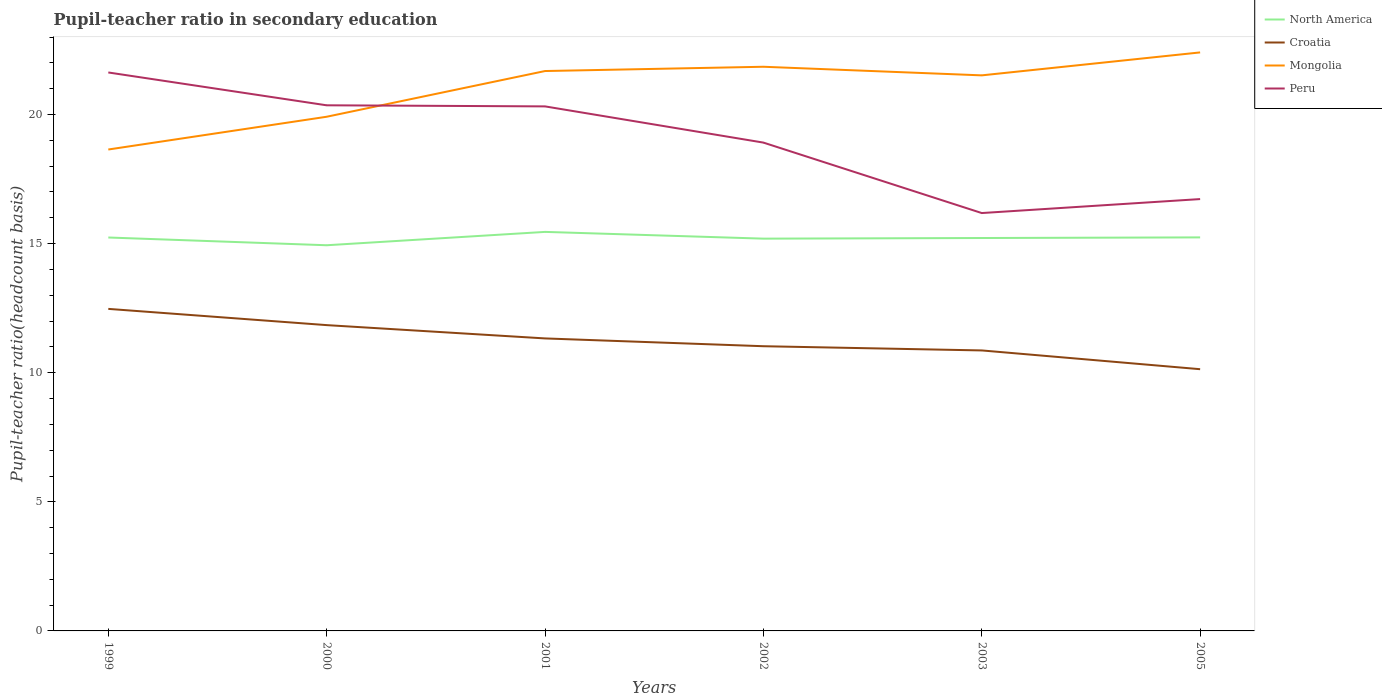How many different coloured lines are there?
Offer a very short reply. 4. Across all years, what is the maximum pupil-teacher ratio in secondary education in North America?
Offer a very short reply. 14.94. In which year was the pupil-teacher ratio in secondary education in North America maximum?
Provide a succinct answer. 2000. What is the total pupil-teacher ratio in secondary education in Peru in the graph?
Give a very brief answer. 1.4. What is the difference between the highest and the second highest pupil-teacher ratio in secondary education in Mongolia?
Your answer should be very brief. 3.76. What is the difference between the highest and the lowest pupil-teacher ratio in secondary education in Croatia?
Your answer should be compact. 3. How many years are there in the graph?
Your response must be concise. 6. What is the difference between two consecutive major ticks on the Y-axis?
Your answer should be very brief. 5. Are the values on the major ticks of Y-axis written in scientific E-notation?
Your response must be concise. No. How many legend labels are there?
Ensure brevity in your answer.  4. What is the title of the graph?
Your answer should be very brief. Pupil-teacher ratio in secondary education. What is the label or title of the X-axis?
Make the answer very short. Years. What is the label or title of the Y-axis?
Ensure brevity in your answer.  Pupil-teacher ratio(headcount basis). What is the Pupil-teacher ratio(headcount basis) of North America in 1999?
Your answer should be very brief. 15.24. What is the Pupil-teacher ratio(headcount basis) of Croatia in 1999?
Give a very brief answer. 12.47. What is the Pupil-teacher ratio(headcount basis) in Mongolia in 1999?
Provide a succinct answer. 18.65. What is the Pupil-teacher ratio(headcount basis) of Peru in 1999?
Provide a succinct answer. 21.63. What is the Pupil-teacher ratio(headcount basis) in North America in 2000?
Your answer should be compact. 14.94. What is the Pupil-teacher ratio(headcount basis) of Croatia in 2000?
Your response must be concise. 11.84. What is the Pupil-teacher ratio(headcount basis) in Mongolia in 2000?
Make the answer very short. 19.91. What is the Pupil-teacher ratio(headcount basis) of Peru in 2000?
Provide a succinct answer. 20.36. What is the Pupil-teacher ratio(headcount basis) in North America in 2001?
Make the answer very short. 15.45. What is the Pupil-teacher ratio(headcount basis) of Croatia in 2001?
Give a very brief answer. 11.33. What is the Pupil-teacher ratio(headcount basis) of Mongolia in 2001?
Your answer should be compact. 21.68. What is the Pupil-teacher ratio(headcount basis) in Peru in 2001?
Offer a terse response. 20.32. What is the Pupil-teacher ratio(headcount basis) of North America in 2002?
Offer a terse response. 15.19. What is the Pupil-teacher ratio(headcount basis) of Croatia in 2002?
Make the answer very short. 11.03. What is the Pupil-teacher ratio(headcount basis) in Mongolia in 2002?
Provide a succinct answer. 21.85. What is the Pupil-teacher ratio(headcount basis) of Peru in 2002?
Provide a short and direct response. 18.91. What is the Pupil-teacher ratio(headcount basis) of North America in 2003?
Your answer should be compact. 15.22. What is the Pupil-teacher ratio(headcount basis) of Croatia in 2003?
Offer a very short reply. 10.86. What is the Pupil-teacher ratio(headcount basis) of Mongolia in 2003?
Offer a very short reply. 21.52. What is the Pupil-teacher ratio(headcount basis) of Peru in 2003?
Give a very brief answer. 16.18. What is the Pupil-teacher ratio(headcount basis) in North America in 2005?
Offer a very short reply. 15.24. What is the Pupil-teacher ratio(headcount basis) in Croatia in 2005?
Your response must be concise. 10.14. What is the Pupil-teacher ratio(headcount basis) of Mongolia in 2005?
Provide a short and direct response. 22.41. What is the Pupil-teacher ratio(headcount basis) of Peru in 2005?
Your response must be concise. 16.73. Across all years, what is the maximum Pupil-teacher ratio(headcount basis) in North America?
Your answer should be compact. 15.45. Across all years, what is the maximum Pupil-teacher ratio(headcount basis) of Croatia?
Offer a very short reply. 12.47. Across all years, what is the maximum Pupil-teacher ratio(headcount basis) in Mongolia?
Give a very brief answer. 22.41. Across all years, what is the maximum Pupil-teacher ratio(headcount basis) of Peru?
Provide a succinct answer. 21.63. Across all years, what is the minimum Pupil-teacher ratio(headcount basis) in North America?
Offer a terse response. 14.94. Across all years, what is the minimum Pupil-teacher ratio(headcount basis) in Croatia?
Offer a very short reply. 10.14. Across all years, what is the minimum Pupil-teacher ratio(headcount basis) of Mongolia?
Your answer should be very brief. 18.65. Across all years, what is the minimum Pupil-teacher ratio(headcount basis) in Peru?
Your answer should be compact. 16.18. What is the total Pupil-teacher ratio(headcount basis) in North America in the graph?
Your response must be concise. 91.28. What is the total Pupil-teacher ratio(headcount basis) in Croatia in the graph?
Your response must be concise. 67.67. What is the total Pupil-teacher ratio(headcount basis) in Mongolia in the graph?
Give a very brief answer. 126.02. What is the total Pupil-teacher ratio(headcount basis) in Peru in the graph?
Keep it short and to the point. 114.13. What is the difference between the Pupil-teacher ratio(headcount basis) in North America in 1999 and that in 2000?
Offer a terse response. 0.3. What is the difference between the Pupil-teacher ratio(headcount basis) of Croatia in 1999 and that in 2000?
Offer a very short reply. 0.63. What is the difference between the Pupil-teacher ratio(headcount basis) in Mongolia in 1999 and that in 2000?
Provide a succinct answer. -1.27. What is the difference between the Pupil-teacher ratio(headcount basis) in Peru in 1999 and that in 2000?
Provide a short and direct response. 1.27. What is the difference between the Pupil-teacher ratio(headcount basis) of North America in 1999 and that in 2001?
Offer a very short reply. -0.22. What is the difference between the Pupil-teacher ratio(headcount basis) in Croatia in 1999 and that in 2001?
Your answer should be compact. 1.14. What is the difference between the Pupil-teacher ratio(headcount basis) of Mongolia in 1999 and that in 2001?
Make the answer very short. -3.04. What is the difference between the Pupil-teacher ratio(headcount basis) of Peru in 1999 and that in 2001?
Offer a very short reply. 1.31. What is the difference between the Pupil-teacher ratio(headcount basis) in North America in 1999 and that in 2002?
Provide a short and direct response. 0.04. What is the difference between the Pupil-teacher ratio(headcount basis) of Croatia in 1999 and that in 2002?
Your answer should be very brief. 1.45. What is the difference between the Pupil-teacher ratio(headcount basis) of Mongolia in 1999 and that in 2002?
Your answer should be compact. -3.21. What is the difference between the Pupil-teacher ratio(headcount basis) in Peru in 1999 and that in 2002?
Offer a terse response. 2.72. What is the difference between the Pupil-teacher ratio(headcount basis) in North America in 1999 and that in 2003?
Your answer should be very brief. 0.02. What is the difference between the Pupil-teacher ratio(headcount basis) of Croatia in 1999 and that in 2003?
Your response must be concise. 1.61. What is the difference between the Pupil-teacher ratio(headcount basis) of Mongolia in 1999 and that in 2003?
Your answer should be compact. -2.87. What is the difference between the Pupil-teacher ratio(headcount basis) in Peru in 1999 and that in 2003?
Your answer should be very brief. 5.44. What is the difference between the Pupil-teacher ratio(headcount basis) of North America in 1999 and that in 2005?
Give a very brief answer. -0. What is the difference between the Pupil-teacher ratio(headcount basis) in Croatia in 1999 and that in 2005?
Offer a very short reply. 2.34. What is the difference between the Pupil-teacher ratio(headcount basis) of Mongolia in 1999 and that in 2005?
Provide a short and direct response. -3.76. What is the difference between the Pupil-teacher ratio(headcount basis) of Peru in 1999 and that in 2005?
Keep it short and to the point. 4.9. What is the difference between the Pupil-teacher ratio(headcount basis) in North America in 2000 and that in 2001?
Your answer should be very brief. -0.52. What is the difference between the Pupil-teacher ratio(headcount basis) of Croatia in 2000 and that in 2001?
Offer a very short reply. 0.52. What is the difference between the Pupil-teacher ratio(headcount basis) in Mongolia in 2000 and that in 2001?
Provide a succinct answer. -1.77. What is the difference between the Pupil-teacher ratio(headcount basis) in Peru in 2000 and that in 2001?
Your answer should be compact. 0.04. What is the difference between the Pupil-teacher ratio(headcount basis) in North America in 2000 and that in 2002?
Provide a succinct answer. -0.26. What is the difference between the Pupil-teacher ratio(headcount basis) of Croatia in 2000 and that in 2002?
Make the answer very short. 0.82. What is the difference between the Pupil-teacher ratio(headcount basis) in Mongolia in 2000 and that in 2002?
Your answer should be very brief. -1.94. What is the difference between the Pupil-teacher ratio(headcount basis) of Peru in 2000 and that in 2002?
Provide a succinct answer. 1.44. What is the difference between the Pupil-teacher ratio(headcount basis) in North America in 2000 and that in 2003?
Make the answer very short. -0.28. What is the difference between the Pupil-teacher ratio(headcount basis) in Croatia in 2000 and that in 2003?
Provide a short and direct response. 0.98. What is the difference between the Pupil-teacher ratio(headcount basis) of Mongolia in 2000 and that in 2003?
Ensure brevity in your answer.  -1.6. What is the difference between the Pupil-teacher ratio(headcount basis) in Peru in 2000 and that in 2003?
Keep it short and to the point. 4.17. What is the difference between the Pupil-teacher ratio(headcount basis) in North America in 2000 and that in 2005?
Provide a short and direct response. -0.3. What is the difference between the Pupil-teacher ratio(headcount basis) in Croatia in 2000 and that in 2005?
Your answer should be compact. 1.71. What is the difference between the Pupil-teacher ratio(headcount basis) of Mongolia in 2000 and that in 2005?
Offer a very short reply. -2.49. What is the difference between the Pupil-teacher ratio(headcount basis) in Peru in 2000 and that in 2005?
Offer a terse response. 3.63. What is the difference between the Pupil-teacher ratio(headcount basis) in North America in 2001 and that in 2002?
Give a very brief answer. 0.26. What is the difference between the Pupil-teacher ratio(headcount basis) of Croatia in 2001 and that in 2002?
Offer a terse response. 0.3. What is the difference between the Pupil-teacher ratio(headcount basis) in Mongolia in 2001 and that in 2002?
Make the answer very short. -0.17. What is the difference between the Pupil-teacher ratio(headcount basis) in Peru in 2001 and that in 2002?
Make the answer very short. 1.4. What is the difference between the Pupil-teacher ratio(headcount basis) in North America in 2001 and that in 2003?
Give a very brief answer. 0.24. What is the difference between the Pupil-teacher ratio(headcount basis) of Croatia in 2001 and that in 2003?
Your answer should be very brief. 0.46. What is the difference between the Pupil-teacher ratio(headcount basis) in Mongolia in 2001 and that in 2003?
Give a very brief answer. 0.17. What is the difference between the Pupil-teacher ratio(headcount basis) in Peru in 2001 and that in 2003?
Offer a terse response. 4.13. What is the difference between the Pupil-teacher ratio(headcount basis) in North America in 2001 and that in 2005?
Ensure brevity in your answer.  0.21. What is the difference between the Pupil-teacher ratio(headcount basis) in Croatia in 2001 and that in 2005?
Offer a very short reply. 1.19. What is the difference between the Pupil-teacher ratio(headcount basis) of Mongolia in 2001 and that in 2005?
Make the answer very short. -0.72. What is the difference between the Pupil-teacher ratio(headcount basis) of Peru in 2001 and that in 2005?
Your response must be concise. 3.59. What is the difference between the Pupil-teacher ratio(headcount basis) of North America in 2002 and that in 2003?
Keep it short and to the point. -0.02. What is the difference between the Pupil-teacher ratio(headcount basis) of Croatia in 2002 and that in 2003?
Offer a very short reply. 0.16. What is the difference between the Pupil-teacher ratio(headcount basis) of Mongolia in 2002 and that in 2003?
Provide a short and direct response. 0.33. What is the difference between the Pupil-teacher ratio(headcount basis) of Peru in 2002 and that in 2003?
Make the answer very short. 2.73. What is the difference between the Pupil-teacher ratio(headcount basis) of North America in 2002 and that in 2005?
Provide a short and direct response. -0.05. What is the difference between the Pupil-teacher ratio(headcount basis) in Croatia in 2002 and that in 2005?
Give a very brief answer. 0.89. What is the difference between the Pupil-teacher ratio(headcount basis) of Mongolia in 2002 and that in 2005?
Ensure brevity in your answer.  -0.56. What is the difference between the Pupil-teacher ratio(headcount basis) of Peru in 2002 and that in 2005?
Keep it short and to the point. 2.19. What is the difference between the Pupil-teacher ratio(headcount basis) in North America in 2003 and that in 2005?
Make the answer very short. -0.02. What is the difference between the Pupil-teacher ratio(headcount basis) in Croatia in 2003 and that in 2005?
Make the answer very short. 0.73. What is the difference between the Pupil-teacher ratio(headcount basis) in Mongolia in 2003 and that in 2005?
Ensure brevity in your answer.  -0.89. What is the difference between the Pupil-teacher ratio(headcount basis) in Peru in 2003 and that in 2005?
Provide a succinct answer. -0.54. What is the difference between the Pupil-teacher ratio(headcount basis) in North America in 1999 and the Pupil-teacher ratio(headcount basis) in Croatia in 2000?
Your answer should be compact. 3.39. What is the difference between the Pupil-teacher ratio(headcount basis) of North America in 1999 and the Pupil-teacher ratio(headcount basis) of Mongolia in 2000?
Offer a terse response. -4.68. What is the difference between the Pupil-teacher ratio(headcount basis) of North America in 1999 and the Pupil-teacher ratio(headcount basis) of Peru in 2000?
Keep it short and to the point. -5.12. What is the difference between the Pupil-teacher ratio(headcount basis) of Croatia in 1999 and the Pupil-teacher ratio(headcount basis) of Mongolia in 2000?
Provide a short and direct response. -7.44. What is the difference between the Pupil-teacher ratio(headcount basis) of Croatia in 1999 and the Pupil-teacher ratio(headcount basis) of Peru in 2000?
Ensure brevity in your answer.  -7.88. What is the difference between the Pupil-teacher ratio(headcount basis) in Mongolia in 1999 and the Pupil-teacher ratio(headcount basis) in Peru in 2000?
Your answer should be compact. -1.71. What is the difference between the Pupil-teacher ratio(headcount basis) in North America in 1999 and the Pupil-teacher ratio(headcount basis) in Croatia in 2001?
Offer a terse response. 3.91. What is the difference between the Pupil-teacher ratio(headcount basis) of North America in 1999 and the Pupil-teacher ratio(headcount basis) of Mongolia in 2001?
Give a very brief answer. -6.45. What is the difference between the Pupil-teacher ratio(headcount basis) of North America in 1999 and the Pupil-teacher ratio(headcount basis) of Peru in 2001?
Make the answer very short. -5.08. What is the difference between the Pupil-teacher ratio(headcount basis) of Croatia in 1999 and the Pupil-teacher ratio(headcount basis) of Mongolia in 2001?
Offer a terse response. -9.21. What is the difference between the Pupil-teacher ratio(headcount basis) in Croatia in 1999 and the Pupil-teacher ratio(headcount basis) in Peru in 2001?
Offer a terse response. -7.84. What is the difference between the Pupil-teacher ratio(headcount basis) of Mongolia in 1999 and the Pupil-teacher ratio(headcount basis) of Peru in 2001?
Your answer should be compact. -1.67. What is the difference between the Pupil-teacher ratio(headcount basis) of North America in 1999 and the Pupil-teacher ratio(headcount basis) of Croatia in 2002?
Offer a very short reply. 4.21. What is the difference between the Pupil-teacher ratio(headcount basis) in North America in 1999 and the Pupil-teacher ratio(headcount basis) in Mongolia in 2002?
Offer a terse response. -6.61. What is the difference between the Pupil-teacher ratio(headcount basis) of North America in 1999 and the Pupil-teacher ratio(headcount basis) of Peru in 2002?
Make the answer very short. -3.68. What is the difference between the Pupil-teacher ratio(headcount basis) of Croatia in 1999 and the Pupil-teacher ratio(headcount basis) of Mongolia in 2002?
Make the answer very short. -9.38. What is the difference between the Pupil-teacher ratio(headcount basis) in Croatia in 1999 and the Pupil-teacher ratio(headcount basis) in Peru in 2002?
Your answer should be very brief. -6.44. What is the difference between the Pupil-teacher ratio(headcount basis) of Mongolia in 1999 and the Pupil-teacher ratio(headcount basis) of Peru in 2002?
Make the answer very short. -0.27. What is the difference between the Pupil-teacher ratio(headcount basis) of North America in 1999 and the Pupil-teacher ratio(headcount basis) of Croatia in 2003?
Your answer should be compact. 4.37. What is the difference between the Pupil-teacher ratio(headcount basis) in North America in 1999 and the Pupil-teacher ratio(headcount basis) in Mongolia in 2003?
Your answer should be very brief. -6.28. What is the difference between the Pupil-teacher ratio(headcount basis) of North America in 1999 and the Pupil-teacher ratio(headcount basis) of Peru in 2003?
Make the answer very short. -0.95. What is the difference between the Pupil-teacher ratio(headcount basis) of Croatia in 1999 and the Pupil-teacher ratio(headcount basis) of Mongolia in 2003?
Provide a succinct answer. -9.04. What is the difference between the Pupil-teacher ratio(headcount basis) in Croatia in 1999 and the Pupil-teacher ratio(headcount basis) in Peru in 2003?
Make the answer very short. -3.71. What is the difference between the Pupil-teacher ratio(headcount basis) in Mongolia in 1999 and the Pupil-teacher ratio(headcount basis) in Peru in 2003?
Keep it short and to the point. 2.46. What is the difference between the Pupil-teacher ratio(headcount basis) of North America in 1999 and the Pupil-teacher ratio(headcount basis) of Croatia in 2005?
Provide a short and direct response. 5.1. What is the difference between the Pupil-teacher ratio(headcount basis) in North America in 1999 and the Pupil-teacher ratio(headcount basis) in Mongolia in 2005?
Your response must be concise. -7.17. What is the difference between the Pupil-teacher ratio(headcount basis) of North America in 1999 and the Pupil-teacher ratio(headcount basis) of Peru in 2005?
Provide a short and direct response. -1.49. What is the difference between the Pupil-teacher ratio(headcount basis) of Croatia in 1999 and the Pupil-teacher ratio(headcount basis) of Mongolia in 2005?
Offer a very short reply. -9.93. What is the difference between the Pupil-teacher ratio(headcount basis) of Croatia in 1999 and the Pupil-teacher ratio(headcount basis) of Peru in 2005?
Keep it short and to the point. -4.25. What is the difference between the Pupil-teacher ratio(headcount basis) in Mongolia in 1999 and the Pupil-teacher ratio(headcount basis) in Peru in 2005?
Give a very brief answer. 1.92. What is the difference between the Pupil-teacher ratio(headcount basis) of North America in 2000 and the Pupil-teacher ratio(headcount basis) of Croatia in 2001?
Your response must be concise. 3.61. What is the difference between the Pupil-teacher ratio(headcount basis) of North America in 2000 and the Pupil-teacher ratio(headcount basis) of Mongolia in 2001?
Your response must be concise. -6.75. What is the difference between the Pupil-teacher ratio(headcount basis) in North America in 2000 and the Pupil-teacher ratio(headcount basis) in Peru in 2001?
Provide a succinct answer. -5.38. What is the difference between the Pupil-teacher ratio(headcount basis) of Croatia in 2000 and the Pupil-teacher ratio(headcount basis) of Mongolia in 2001?
Provide a succinct answer. -9.84. What is the difference between the Pupil-teacher ratio(headcount basis) in Croatia in 2000 and the Pupil-teacher ratio(headcount basis) in Peru in 2001?
Provide a short and direct response. -8.47. What is the difference between the Pupil-teacher ratio(headcount basis) in Mongolia in 2000 and the Pupil-teacher ratio(headcount basis) in Peru in 2001?
Provide a succinct answer. -0.4. What is the difference between the Pupil-teacher ratio(headcount basis) of North America in 2000 and the Pupil-teacher ratio(headcount basis) of Croatia in 2002?
Ensure brevity in your answer.  3.91. What is the difference between the Pupil-teacher ratio(headcount basis) in North America in 2000 and the Pupil-teacher ratio(headcount basis) in Mongolia in 2002?
Offer a terse response. -6.91. What is the difference between the Pupil-teacher ratio(headcount basis) in North America in 2000 and the Pupil-teacher ratio(headcount basis) in Peru in 2002?
Provide a short and direct response. -3.98. What is the difference between the Pupil-teacher ratio(headcount basis) of Croatia in 2000 and the Pupil-teacher ratio(headcount basis) of Mongolia in 2002?
Give a very brief answer. -10.01. What is the difference between the Pupil-teacher ratio(headcount basis) of Croatia in 2000 and the Pupil-teacher ratio(headcount basis) of Peru in 2002?
Keep it short and to the point. -7.07. What is the difference between the Pupil-teacher ratio(headcount basis) of North America in 2000 and the Pupil-teacher ratio(headcount basis) of Croatia in 2003?
Give a very brief answer. 4.07. What is the difference between the Pupil-teacher ratio(headcount basis) of North America in 2000 and the Pupil-teacher ratio(headcount basis) of Mongolia in 2003?
Make the answer very short. -6.58. What is the difference between the Pupil-teacher ratio(headcount basis) in North America in 2000 and the Pupil-teacher ratio(headcount basis) in Peru in 2003?
Make the answer very short. -1.25. What is the difference between the Pupil-teacher ratio(headcount basis) in Croatia in 2000 and the Pupil-teacher ratio(headcount basis) in Mongolia in 2003?
Offer a terse response. -9.67. What is the difference between the Pupil-teacher ratio(headcount basis) of Croatia in 2000 and the Pupil-teacher ratio(headcount basis) of Peru in 2003?
Offer a terse response. -4.34. What is the difference between the Pupil-teacher ratio(headcount basis) of Mongolia in 2000 and the Pupil-teacher ratio(headcount basis) of Peru in 2003?
Keep it short and to the point. 3.73. What is the difference between the Pupil-teacher ratio(headcount basis) in North America in 2000 and the Pupil-teacher ratio(headcount basis) in Croatia in 2005?
Your response must be concise. 4.8. What is the difference between the Pupil-teacher ratio(headcount basis) of North America in 2000 and the Pupil-teacher ratio(headcount basis) of Mongolia in 2005?
Give a very brief answer. -7.47. What is the difference between the Pupil-teacher ratio(headcount basis) in North America in 2000 and the Pupil-teacher ratio(headcount basis) in Peru in 2005?
Provide a succinct answer. -1.79. What is the difference between the Pupil-teacher ratio(headcount basis) of Croatia in 2000 and the Pupil-teacher ratio(headcount basis) of Mongolia in 2005?
Provide a short and direct response. -10.56. What is the difference between the Pupil-teacher ratio(headcount basis) in Croatia in 2000 and the Pupil-teacher ratio(headcount basis) in Peru in 2005?
Provide a short and direct response. -4.88. What is the difference between the Pupil-teacher ratio(headcount basis) of Mongolia in 2000 and the Pupil-teacher ratio(headcount basis) of Peru in 2005?
Offer a very short reply. 3.19. What is the difference between the Pupil-teacher ratio(headcount basis) in North America in 2001 and the Pupil-teacher ratio(headcount basis) in Croatia in 2002?
Offer a very short reply. 4.43. What is the difference between the Pupil-teacher ratio(headcount basis) in North America in 2001 and the Pupil-teacher ratio(headcount basis) in Mongolia in 2002?
Your response must be concise. -6.4. What is the difference between the Pupil-teacher ratio(headcount basis) of North America in 2001 and the Pupil-teacher ratio(headcount basis) of Peru in 2002?
Make the answer very short. -3.46. What is the difference between the Pupil-teacher ratio(headcount basis) in Croatia in 2001 and the Pupil-teacher ratio(headcount basis) in Mongolia in 2002?
Make the answer very short. -10.52. What is the difference between the Pupil-teacher ratio(headcount basis) in Croatia in 2001 and the Pupil-teacher ratio(headcount basis) in Peru in 2002?
Offer a very short reply. -7.58. What is the difference between the Pupil-teacher ratio(headcount basis) of Mongolia in 2001 and the Pupil-teacher ratio(headcount basis) of Peru in 2002?
Offer a terse response. 2.77. What is the difference between the Pupil-teacher ratio(headcount basis) in North America in 2001 and the Pupil-teacher ratio(headcount basis) in Croatia in 2003?
Offer a terse response. 4.59. What is the difference between the Pupil-teacher ratio(headcount basis) in North America in 2001 and the Pupil-teacher ratio(headcount basis) in Mongolia in 2003?
Offer a terse response. -6.06. What is the difference between the Pupil-teacher ratio(headcount basis) in North America in 2001 and the Pupil-teacher ratio(headcount basis) in Peru in 2003?
Keep it short and to the point. -0.73. What is the difference between the Pupil-teacher ratio(headcount basis) of Croatia in 2001 and the Pupil-teacher ratio(headcount basis) of Mongolia in 2003?
Your answer should be very brief. -10.19. What is the difference between the Pupil-teacher ratio(headcount basis) of Croatia in 2001 and the Pupil-teacher ratio(headcount basis) of Peru in 2003?
Provide a succinct answer. -4.86. What is the difference between the Pupil-teacher ratio(headcount basis) of Mongolia in 2001 and the Pupil-teacher ratio(headcount basis) of Peru in 2003?
Give a very brief answer. 5.5. What is the difference between the Pupil-teacher ratio(headcount basis) in North America in 2001 and the Pupil-teacher ratio(headcount basis) in Croatia in 2005?
Your answer should be compact. 5.32. What is the difference between the Pupil-teacher ratio(headcount basis) in North America in 2001 and the Pupil-teacher ratio(headcount basis) in Mongolia in 2005?
Offer a very short reply. -6.95. What is the difference between the Pupil-teacher ratio(headcount basis) of North America in 2001 and the Pupil-teacher ratio(headcount basis) of Peru in 2005?
Make the answer very short. -1.27. What is the difference between the Pupil-teacher ratio(headcount basis) in Croatia in 2001 and the Pupil-teacher ratio(headcount basis) in Mongolia in 2005?
Your answer should be compact. -11.08. What is the difference between the Pupil-teacher ratio(headcount basis) of Croatia in 2001 and the Pupil-teacher ratio(headcount basis) of Peru in 2005?
Your response must be concise. -5.4. What is the difference between the Pupil-teacher ratio(headcount basis) of Mongolia in 2001 and the Pupil-teacher ratio(headcount basis) of Peru in 2005?
Your answer should be very brief. 4.96. What is the difference between the Pupil-teacher ratio(headcount basis) in North America in 2002 and the Pupil-teacher ratio(headcount basis) in Croatia in 2003?
Provide a short and direct response. 4.33. What is the difference between the Pupil-teacher ratio(headcount basis) in North America in 2002 and the Pupil-teacher ratio(headcount basis) in Mongolia in 2003?
Keep it short and to the point. -6.32. What is the difference between the Pupil-teacher ratio(headcount basis) in North America in 2002 and the Pupil-teacher ratio(headcount basis) in Peru in 2003?
Your answer should be compact. -0.99. What is the difference between the Pupil-teacher ratio(headcount basis) in Croatia in 2002 and the Pupil-teacher ratio(headcount basis) in Mongolia in 2003?
Provide a short and direct response. -10.49. What is the difference between the Pupil-teacher ratio(headcount basis) in Croatia in 2002 and the Pupil-teacher ratio(headcount basis) in Peru in 2003?
Your answer should be compact. -5.16. What is the difference between the Pupil-teacher ratio(headcount basis) in Mongolia in 2002 and the Pupil-teacher ratio(headcount basis) in Peru in 2003?
Offer a very short reply. 5.67. What is the difference between the Pupil-teacher ratio(headcount basis) of North America in 2002 and the Pupil-teacher ratio(headcount basis) of Croatia in 2005?
Provide a short and direct response. 5.06. What is the difference between the Pupil-teacher ratio(headcount basis) in North America in 2002 and the Pupil-teacher ratio(headcount basis) in Mongolia in 2005?
Give a very brief answer. -7.21. What is the difference between the Pupil-teacher ratio(headcount basis) in North America in 2002 and the Pupil-teacher ratio(headcount basis) in Peru in 2005?
Your response must be concise. -1.53. What is the difference between the Pupil-teacher ratio(headcount basis) in Croatia in 2002 and the Pupil-teacher ratio(headcount basis) in Mongolia in 2005?
Offer a terse response. -11.38. What is the difference between the Pupil-teacher ratio(headcount basis) of Croatia in 2002 and the Pupil-teacher ratio(headcount basis) of Peru in 2005?
Make the answer very short. -5.7. What is the difference between the Pupil-teacher ratio(headcount basis) of Mongolia in 2002 and the Pupil-teacher ratio(headcount basis) of Peru in 2005?
Provide a short and direct response. 5.12. What is the difference between the Pupil-teacher ratio(headcount basis) in North America in 2003 and the Pupil-teacher ratio(headcount basis) in Croatia in 2005?
Keep it short and to the point. 5.08. What is the difference between the Pupil-teacher ratio(headcount basis) in North America in 2003 and the Pupil-teacher ratio(headcount basis) in Mongolia in 2005?
Provide a succinct answer. -7.19. What is the difference between the Pupil-teacher ratio(headcount basis) in North America in 2003 and the Pupil-teacher ratio(headcount basis) in Peru in 2005?
Ensure brevity in your answer.  -1.51. What is the difference between the Pupil-teacher ratio(headcount basis) in Croatia in 2003 and the Pupil-teacher ratio(headcount basis) in Mongolia in 2005?
Your answer should be compact. -11.54. What is the difference between the Pupil-teacher ratio(headcount basis) in Croatia in 2003 and the Pupil-teacher ratio(headcount basis) in Peru in 2005?
Offer a terse response. -5.86. What is the difference between the Pupil-teacher ratio(headcount basis) of Mongolia in 2003 and the Pupil-teacher ratio(headcount basis) of Peru in 2005?
Ensure brevity in your answer.  4.79. What is the average Pupil-teacher ratio(headcount basis) of North America per year?
Provide a succinct answer. 15.21. What is the average Pupil-teacher ratio(headcount basis) of Croatia per year?
Provide a succinct answer. 11.28. What is the average Pupil-teacher ratio(headcount basis) in Mongolia per year?
Keep it short and to the point. 21. What is the average Pupil-teacher ratio(headcount basis) of Peru per year?
Offer a terse response. 19.02. In the year 1999, what is the difference between the Pupil-teacher ratio(headcount basis) of North America and Pupil-teacher ratio(headcount basis) of Croatia?
Your answer should be very brief. 2.76. In the year 1999, what is the difference between the Pupil-teacher ratio(headcount basis) in North America and Pupil-teacher ratio(headcount basis) in Mongolia?
Your answer should be compact. -3.41. In the year 1999, what is the difference between the Pupil-teacher ratio(headcount basis) of North America and Pupil-teacher ratio(headcount basis) of Peru?
Your answer should be very brief. -6.39. In the year 1999, what is the difference between the Pupil-teacher ratio(headcount basis) of Croatia and Pupil-teacher ratio(headcount basis) of Mongolia?
Your answer should be compact. -6.17. In the year 1999, what is the difference between the Pupil-teacher ratio(headcount basis) of Croatia and Pupil-teacher ratio(headcount basis) of Peru?
Provide a short and direct response. -9.16. In the year 1999, what is the difference between the Pupil-teacher ratio(headcount basis) in Mongolia and Pupil-teacher ratio(headcount basis) in Peru?
Your answer should be compact. -2.98. In the year 2000, what is the difference between the Pupil-teacher ratio(headcount basis) in North America and Pupil-teacher ratio(headcount basis) in Croatia?
Provide a short and direct response. 3.09. In the year 2000, what is the difference between the Pupil-teacher ratio(headcount basis) in North America and Pupil-teacher ratio(headcount basis) in Mongolia?
Provide a short and direct response. -4.98. In the year 2000, what is the difference between the Pupil-teacher ratio(headcount basis) of North America and Pupil-teacher ratio(headcount basis) of Peru?
Give a very brief answer. -5.42. In the year 2000, what is the difference between the Pupil-teacher ratio(headcount basis) of Croatia and Pupil-teacher ratio(headcount basis) of Mongolia?
Provide a succinct answer. -8.07. In the year 2000, what is the difference between the Pupil-teacher ratio(headcount basis) of Croatia and Pupil-teacher ratio(headcount basis) of Peru?
Your response must be concise. -8.51. In the year 2000, what is the difference between the Pupil-teacher ratio(headcount basis) in Mongolia and Pupil-teacher ratio(headcount basis) in Peru?
Ensure brevity in your answer.  -0.44. In the year 2001, what is the difference between the Pupil-teacher ratio(headcount basis) of North America and Pupil-teacher ratio(headcount basis) of Croatia?
Ensure brevity in your answer.  4.13. In the year 2001, what is the difference between the Pupil-teacher ratio(headcount basis) of North America and Pupil-teacher ratio(headcount basis) of Mongolia?
Your answer should be compact. -6.23. In the year 2001, what is the difference between the Pupil-teacher ratio(headcount basis) in North America and Pupil-teacher ratio(headcount basis) in Peru?
Give a very brief answer. -4.86. In the year 2001, what is the difference between the Pupil-teacher ratio(headcount basis) in Croatia and Pupil-teacher ratio(headcount basis) in Mongolia?
Offer a very short reply. -10.36. In the year 2001, what is the difference between the Pupil-teacher ratio(headcount basis) in Croatia and Pupil-teacher ratio(headcount basis) in Peru?
Make the answer very short. -8.99. In the year 2001, what is the difference between the Pupil-teacher ratio(headcount basis) of Mongolia and Pupil-teacher ratio(headcount basis) of Peru?
Your answer should be compact. 1.37. In the year 2002, what is the difference between the Pupil-teacher ratio(headcount basis) of North America and Pupil-teacher ratio(headcount basis) of Croatia?
Keep it short and to the point. 4.17. In the year 2002, what is the difference between the Pupil-teacher ratio(headcount basis) of North America and Pupil-teacher ratio(headcount basis) of Mongolia?
Give a very brief answer. -6.66. In the year 2002, what is the difference between the Pupil-teacher ratio(headcount basis) of North America and Pupil-teacher ratio(headcount basis) of Peru?
Offer a very short reply. -3.72. In the year 2002, what is the difference between the Pupil-teacher ratio(headcount basis) of Croatia and Pupil-teacher ratio(headcount basis) of Mongolia?
Your response must be concise. -10.82. In the year 2002, what is the difference between the Pupil-teacher ratio(headcount basis) in Croatia and Pupil-teacher ratio(headcount basis) in Peru?
Make the answer very short. -7.89. In the year 2002, what is the difference between the Pupil-teacher ratio(headcount basis) in Mongolia and Pupil-teacher ratio(headcount basis) in Peru?
Offer a terse response. 2.94. In the year 2003, what is the difference between the Pupil-teacher ratio(headcount basis) of North America and Pupil-teacher ratio(headcount basis) of Croatia?
Give a very brief answer. 4.35. In the year 2003, what is the difference between the Pupil-teacher ratio(headcount basis) in North America and Pupil-teacher ratio(headcount basis) in Mongolia?
Your answer should be compact. -6.3. In the year 2003, what is the difference between the Pupil-teacher ratio(headcount basis) of North America and Pupil-teacher ratio(headcount basis) of Peru?
Provide a short and direct response. -0.97. In the year 2003, what is the difference between the Pupil-teacher ratio(headcount basis) of Croatia and Pupil-teacher ratio(headcount basis) of Mongolia?
Your answer should be compact. -10.65. In the year 2003, what is the difference between the Pupil-teacher ratio(headcount basis) of Croatia and Pupil-teacher ratio(headcount basis) of Peru?
Offer a very short reply. -5.32. In the year 2003, what is the difference between the Pupil-teacher ratio(headcount basis) of Mongolia and Pupil-teacher ratio(headcount basis) of Peru?
Provide a succinct answer. 5.33. In the year 2005, what is the difference between the Pupil-teacher ratio(headcount basis) of North America and Pupil-teacher ratio(headcount basis) of Croatia?
Your answer should be very brief. 5.1. In the year 2005, what is the difference between the Pupil-teacher ratio(headcount basis) of North America and Pupil-teacher ratio(headcount basis) of Mongolia?
Offer a terse response. -7.16. In the year 2005, what is the difference between the Pupil-teacher ratio(headcount basis) of North America and Pupil-teacher ratio(headcount basis) of Peru?
Keep it short and to the point. -1.48. In the year 2005, what is the difference between the Pupil-teacher ratio(headcount basis) of Croatia and Pupil-teacher ratio(headcount basis) of Mongolia?
Keep it short and to the point. -12.27. In the year 2005, what is the difference between the Pupil-teacher ratio(headcount basis) in Croatia and Pupil-teacher ratio(headcount basis) in Peru?
Offer a terse response. -6.59. In the year 2005, what is the difference between the Pupil-teacher ratio(headcount basis) of Mongolia and Pupil-teacher ratio(headcount basis) of Peru?
Make the answer very short. 5.68. What is the ratio of the Pupil-teacher ratio(headcount basis) in North America in 1999 to that in 2000?
Make the answer very short. 1.02. What is the ratio of the Pupil-teacher ratio(headcount basis) of Croatia in 1999 to that in 2000?
Provide a succinct answer. 1.05. What is the ratio of the Pupil-teacher ratio(headcount basis) in Mongolia in 1999 to that in 2000?
Provide a short and direct response. 0.94. What is the ratio of the Pupil-teacher ratio(headcount basis) in North America in 1999 to that in 2001?
Your answer should be very brief. 0.99. What is the ratio of the Pupil-teacher ratio(headcount basis) of Croatia in 1999 to that in 2001?
Keep it short and to the point. 1.1. What is the ratio of the Pupil-teacher ratio(headcount basis) of Mongolia in 1999 to that in 2001?
Give a very brief answer. 0.86. What is the ratio of the Pupil-teacher ratio(headcount basis) in Peru in 1999 to that in 2001?
Ensure brevity in your answer.  1.06. What is the ratio of the Pupil-teacher ratio(headcount basis) in Croatia in 1999 to that in 2002?
Keep it short and to the point. 1.13. What is the ratio of the Pupil-teacher ratio(headcount basis) in Mongolia in 1999 to that in 2002?
Your answer should be very brief. 0.85. What is the ratio of the Pupil-teacher ratio(headcount basis) of Peru in 1999 to that in 2002?
Your answer should be very brief. 1.14. What is the ratio of the Pupil-teacher ratio(headcount basis) of Croatia in 1999 to that in 2003?
Offer a terse response. 1.15. What is the ratio of the Pupil-teacher ratio(headcount basis) in Mongolia in 1999 to that in 2003?
Offer a terse response. 0.87. What is the ratio of the Pupil-teacher ratio(headcount basis) in Peru in 1999 to that in 2003?
Offer a terse response. 1.34. What is the ratio of the Pupil-teacher ratio(headcount basis) in North America in 1999 to that in 2005?
Ensure brevity in your answer.  1. What is the ratio of the Pupil-teacher ratio(headcount basis) in Croatia in 1999 to that in 2005?
Your response must be concise. 1.23. What is the ratio of the Pupil-teacher ratio(headcount basis) of Mongolia in 1999 to that in 2005?
Your answer should be compact. 0.83. What is the ratio of the Pupil-teacher ratio(headcount basis) in Peru in 1999 to that in 2005?
Ensure brevity in your answer.  1.29. What is the ratio of the Pupil-teacher ratio(headcount basis) in North America in 2000 to that in 2001?
Ensure brevity in your answer.  0.97. What is the ratio of the Pupil-teacher ratio(headcount basis) of Croatia in 2000 to that in 2001?
Ensure brevity in your answer.  1.05. What is the ratio of the Pupil-teacher ratio(headcount basis) in Mongolia in 2000 to that in 2001?
Provide a succinct answer. 0.92. What is the ratio of the Pupil-teacher ratio(headcount basis) in North America in 2000 to that in 2002?
Offer a terse response. 0.98. What is the ratio of the Pupil-teacher ratio(headcount basis) of Croatia in 2000 to that in 2002?
Offer a terse response. 1.07. What is the ratio of the Pupil-teacher ratio(headcount basis) of Mongolia in 2000 to that in 2002?
Keep it short and to the point. 0.91. What is the ratio of the Pupil-teacher ratio(headcount basis) of Peru in 2000 to that in 2002?
Offer a terse response. 1.08. What is the ratio of the Pupil-teacher ratio(headcount basis) in North America in 2000 to that in 2003?
Your answer should be very brief. 0.98. What is the ratio of the Pupil-teacher ratio(headcount basis) of Croatia in 2000 to that in 2003?
Your response must be concise. 1.09. What is the ratio of the Pupil-teacher ratio(headcount basis) in Mongolia in 2000 to that in 2003?
Give a very brief answer. 0.93. What is the ratio of the Pupil-teacher ratio(headcount basis) in Peru in 2000 to that in 2003?
Offer a terse response. 1.26. What is the ratio of the Pupil-teacher ratio(headcount basis) in Croatia in 2000 to that in 2005?
Keep it short and to the point. 1.17. What is the ratio of the Pupil-teacher ratio(headcount basis) in Mongolia in 2000 to that in 2005?
Your answer should be compact. 0.89. What is the ratio of the Pupil-teacher ratio(headcount basis) in Peru in 2000 to that in 2005?
Your answer should be compact. 1.22. What is the ratio of the Pupil-teacher ratio(headcount basis) in North America in 2001 to that in 2002?
Make the answer very short. 1.02. What is the ratio of the Pupil-teacher ratio(headcount basis) in Croatia in 2001 to that in 2002?
Provide a short and direct response. 1.03. What is the ratio of the Pupil-teacher ratio(headcount basis) in Peru in 2001 to that in 2002?
Your response must be concise. 1.07. What is the ratio of the Pupil-teacher ratio(headcount basis) in North America in 2001 to that in 2003?
Give a very brief answer. 1.02. What is the ratio of the Pupil-teacher ratio(headcount basis) in Croatia in 2001 to that in 2003?
Offer a terse response. 1.04. What is the ratio of the Pupil-teacher ratio(headcount basis) of Mongolia in 2001 to that in 2003?
Ensure brevity in your answer.  1.01. What is the ratio of the Pupil-teacher ratio(headcount basis) of Peru in 2001 to that in 2003?
Ensure brevity in your answer.  1.26. What is the ratio of the Pupil-teacher ratio(headcount basis) of North America in 2001 to that in 2005?
Your answer should be compact. 1.01. What is the ratio of the Pupil-teacher ratio(headcount basis) in Croatia in 2001 to that in 2005?
Your answer should be compact. 1.12. What is the ratio of the Pupil-teacher ratio(headcount basis) of Mongolia in 2001 to that in 2005?
Your answer should be compact. 0.97. What is the ratio of the Pupil-teacher ratio(headcount basis) of Peru in 2001 to that in 2005?
Provide a succinct answer. 1.21. What is the ratio of the Pupil-teacher ratio(headcount basis) in North America in 2002 to that in 2003?
Ensure brevity in your answer.  1. What is the ratio of the Pupil-teacher ratio(headcount basis) of Croatia in 2002 to that in 2003?
Provide a short and direct response. 1.01. What is the ratio of the Pupil-teacher ratio(headcount basis) of Mongolia in 2002 to that in 2003?
Provide a succinct answer. 1.02. What is the ratio of the Pupil-teacher ratio(headcount basis) of Peru in 2002 to that in 2003?
Ensure brevity in your answer.  1.17. What is the ratio of the Pupil-teacher ratio(headcount basis) in Croatia in 2002 to that in 2005?
Make the answer very short. 1.09. What is the ratio of the Pupil-teacher ratio(headcount basis) in Mongolia in 2002 to that in 2005?
Make the answer very short. 0.98. What is the ratio of the Pupil-teacher ratio(headcount basis) of Peru in 2002 to that in 2005?
Offer a very short reply. 1.13. What is the ratio of the Pupil-teacher ratio(headcount basis) in Croatia in 2003 to that in 2005?
Your answer should be compact. 1.07. What is the ratio of the Pupil-teacher ratio(headcount basis) in Mongolia in 2003 to that in 2005?
Your response must be concise. 0.96. What is the ratio of the Pupil-teacher ratio(headcount basis) of Peru in 2003 to that in 2005?
Ensure brevity in your answer.  0.97. What is the difference between the highest and the second highest Pupil-teacher ratio(headcount basis) in North America?
Provide a short and direct response. 0.21. What is the difference between the highest and the second highest Pupil-teacher ratio(headcount basis) in Croatia?
Your response must be concise. 0.63. What is the difference between the highest and the second highest Pupil-teacher ratio(headcount basis) of Mongolia?
Your response must be concise. 0.56. What is the difference between the highest and the second highest Pupil-teacher ratio(headcount basis) in Peru?
Ensure brevity in your answer.  1.27. What is the difference between the highest and the lowest Pupil-teacher ratio(headcount basis) of North America?
Offer a very short reply. 0.52. What is the difference between the highest and the lowest Pupil-teacher ratio(headcount basis) in Croatia?
Give a very brief answer. 2.34. What is the difference between the highest and the lowest Pupil-teacher ratio(headcount basis) in Mongolia?
Your response must be concise. 3.76. What is the difference between the highest and the lowest Pupil-teacher ratio(headcount basis) of Peru?
Keep it short and to the point. 5.44. 